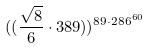<formula> <loc_0><loc_0><loc_500><loc_500>( ( \frac { \sqrt { 8 } } { 6 } \cdot 3 8 9 ) ) ^ { 8 9 \cdot 2 8 6 ^ { 6 0 } }</formula> 